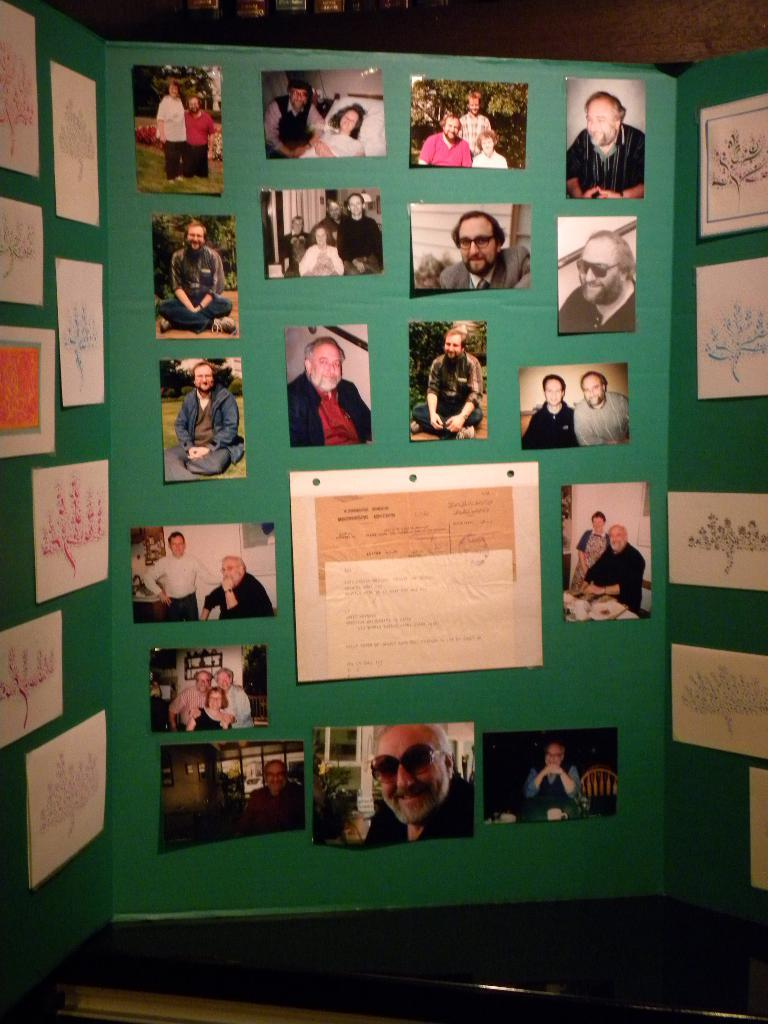What type of items can be seen in the image? There are photos, papers, and cards with designs in the image. How are the cards with designs arranged in the image? The cards with designs are stuck to a green color card. What is the green color card placed on in the image? The green color card is on a book. Can you tell me how many people are visible in the image? There are no people visible in the image; it features photos, papers, and cards with designs. What type of fruit is being used to power the cards with designs in the image? There is no fruit, such as a cherry, present in the image, and the cards with designs are not powered by any fruit. 